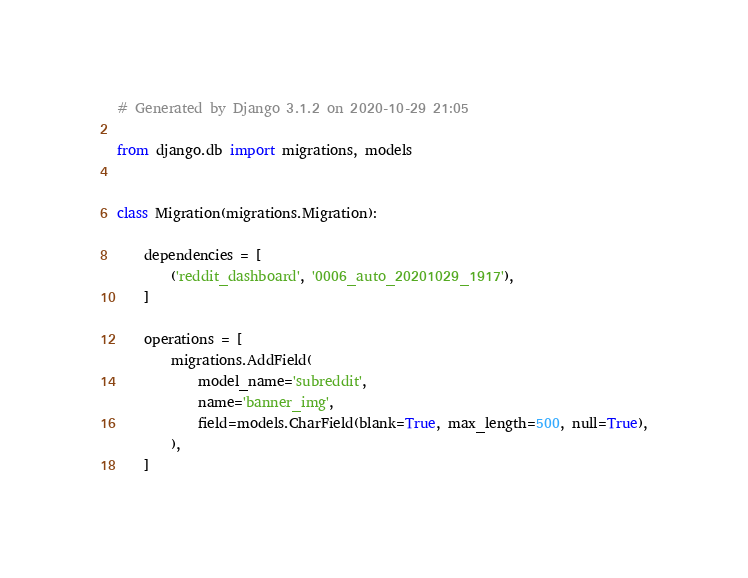Convert code to text. <code><loc_0><loc_0><loc_500><loc_500><_Python_># Generated by Django 3.1.2 on 2020-10-29 21:05

from django.db import migrations, models


class Migration(migrations.Migration):

    dependencies = [
        ('reddit_dashboard', '0006_auto_20201029_1917'),
    ]

    operations = [
        migrations.AddField(
            model_name='subreddit',
            name='banner_img',
            field=models.CharField(blank=True, max_length=500, null=True),
        ),
    ]
</code> 